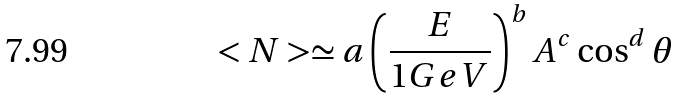Convert formula to latex. <formula><loc_0><loc_0><loc_500><loc_500>< N > \simeq a \left ( \frac { E } { 1 G e V } \right ) ^ { b } A ^ { c } \cos ^ { d } \theta</formula> 